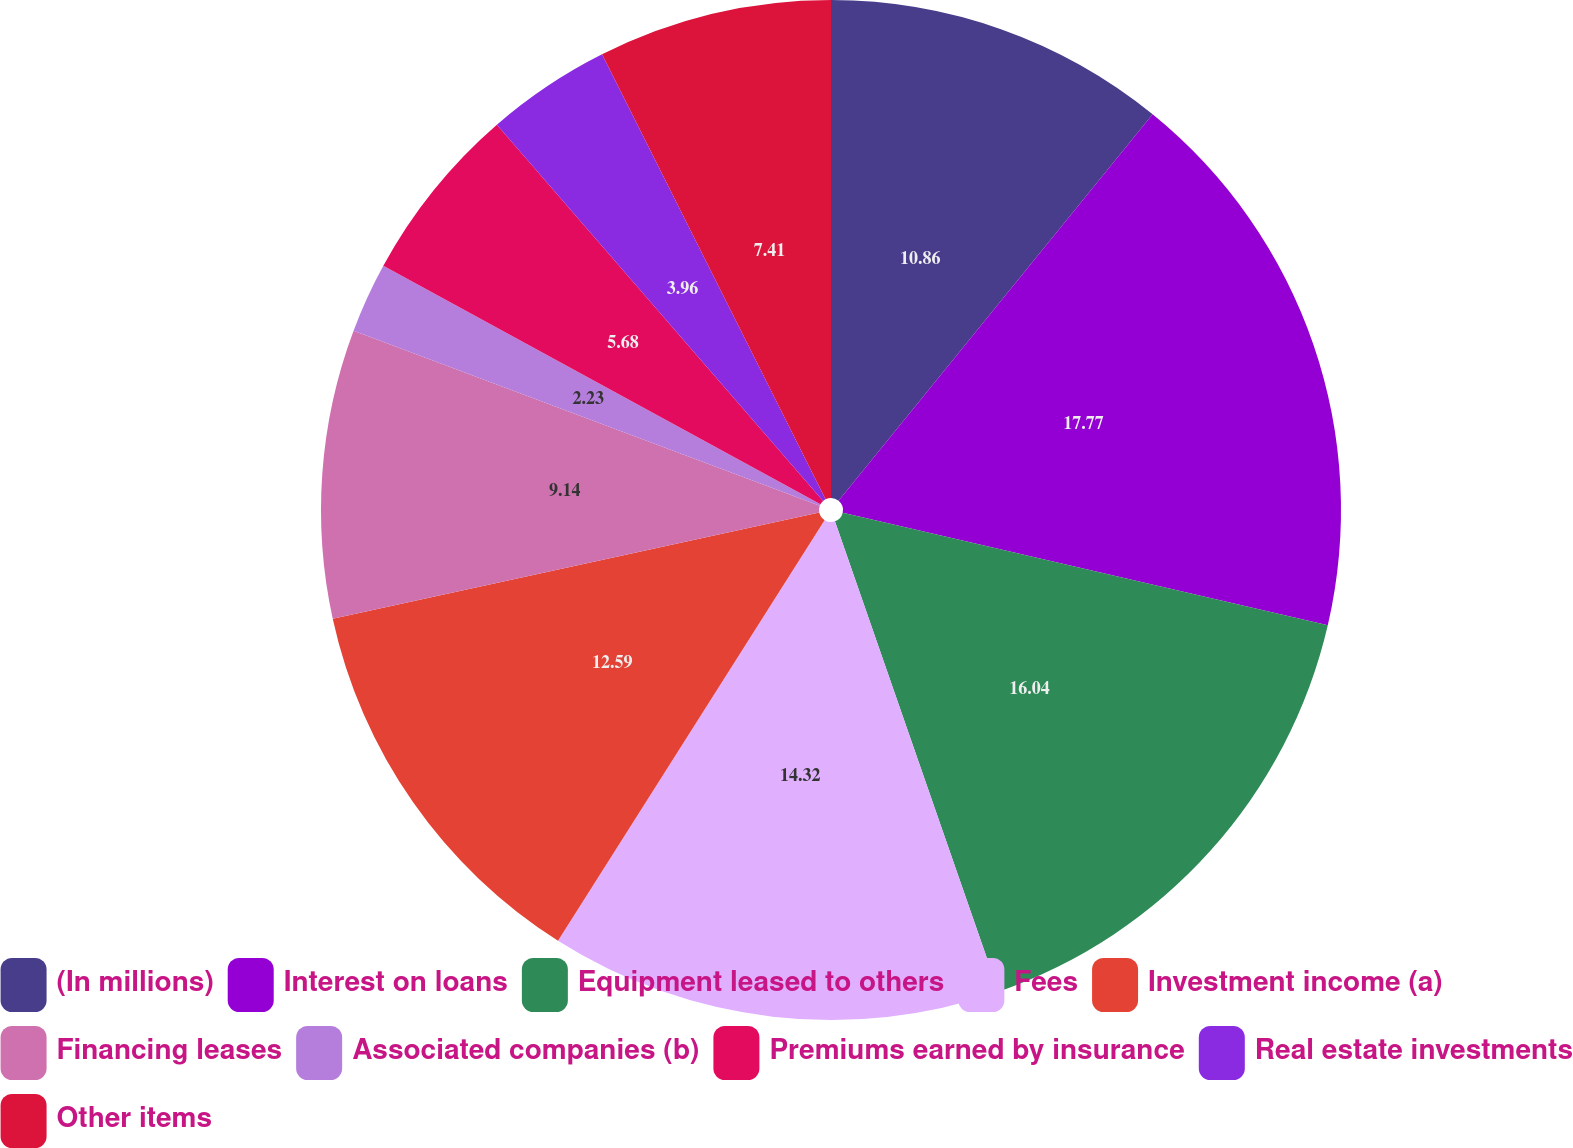<chart> <loc_0><loc_0><loc_500><loc_500><pie_chart><fcel>(In millions)<fcel>Interest on loans<fcel>Equipment leased to others<fcel>Fees<fcel>Investment income (a)<fcel>Financing leases<fcel>Associated companies (b)<fcel>Premiums earned by insurance<fcel>Real estate investments<fcel>Other items<nl><fcel>10.86%<fcel>17.77%<fcel>16.04%<fcel>14.32%<fcel>12.59%<fcel>9.14%<fcel>2.23%<fcel>5.68%<fcel>3.96%<fcel>7.41%<nl></chart> 